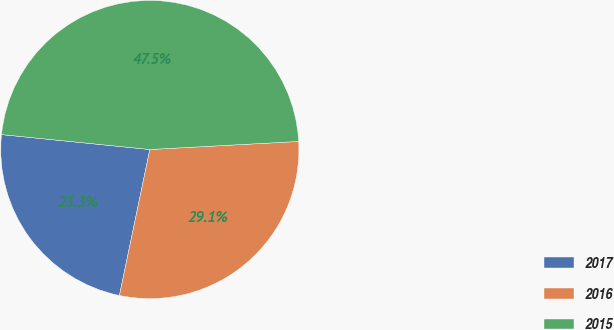Convert chart. <chart><loc_0><loc_0><loc_500><loc_500><pie_chart><fcel>2017<fcel>2016<fcel>2015<nl><fcel>23.33%<fcel>29.13%<fcel>47.54%<nl></chart> 